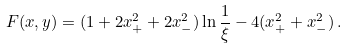Convert formula to latex. <formula><loc_0><loc_0><loc_500><loc_500>F ( x , y ) = ( 1 + 2 x _ { + } ^ { 2 } + 2 x _ { - } ^ { 2 } ) \ln \frac { 1 } { \xi } - 4 ( x _ { + } ^ { 2 } + x _ { - } ^ { 2 } ) \, .</formula> 